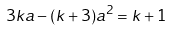<formula> <loc_0><loc_0><loc_500><loc_500>3 k a - ( k + 3 ) a ^ { 2 } = k + 1</formula> 